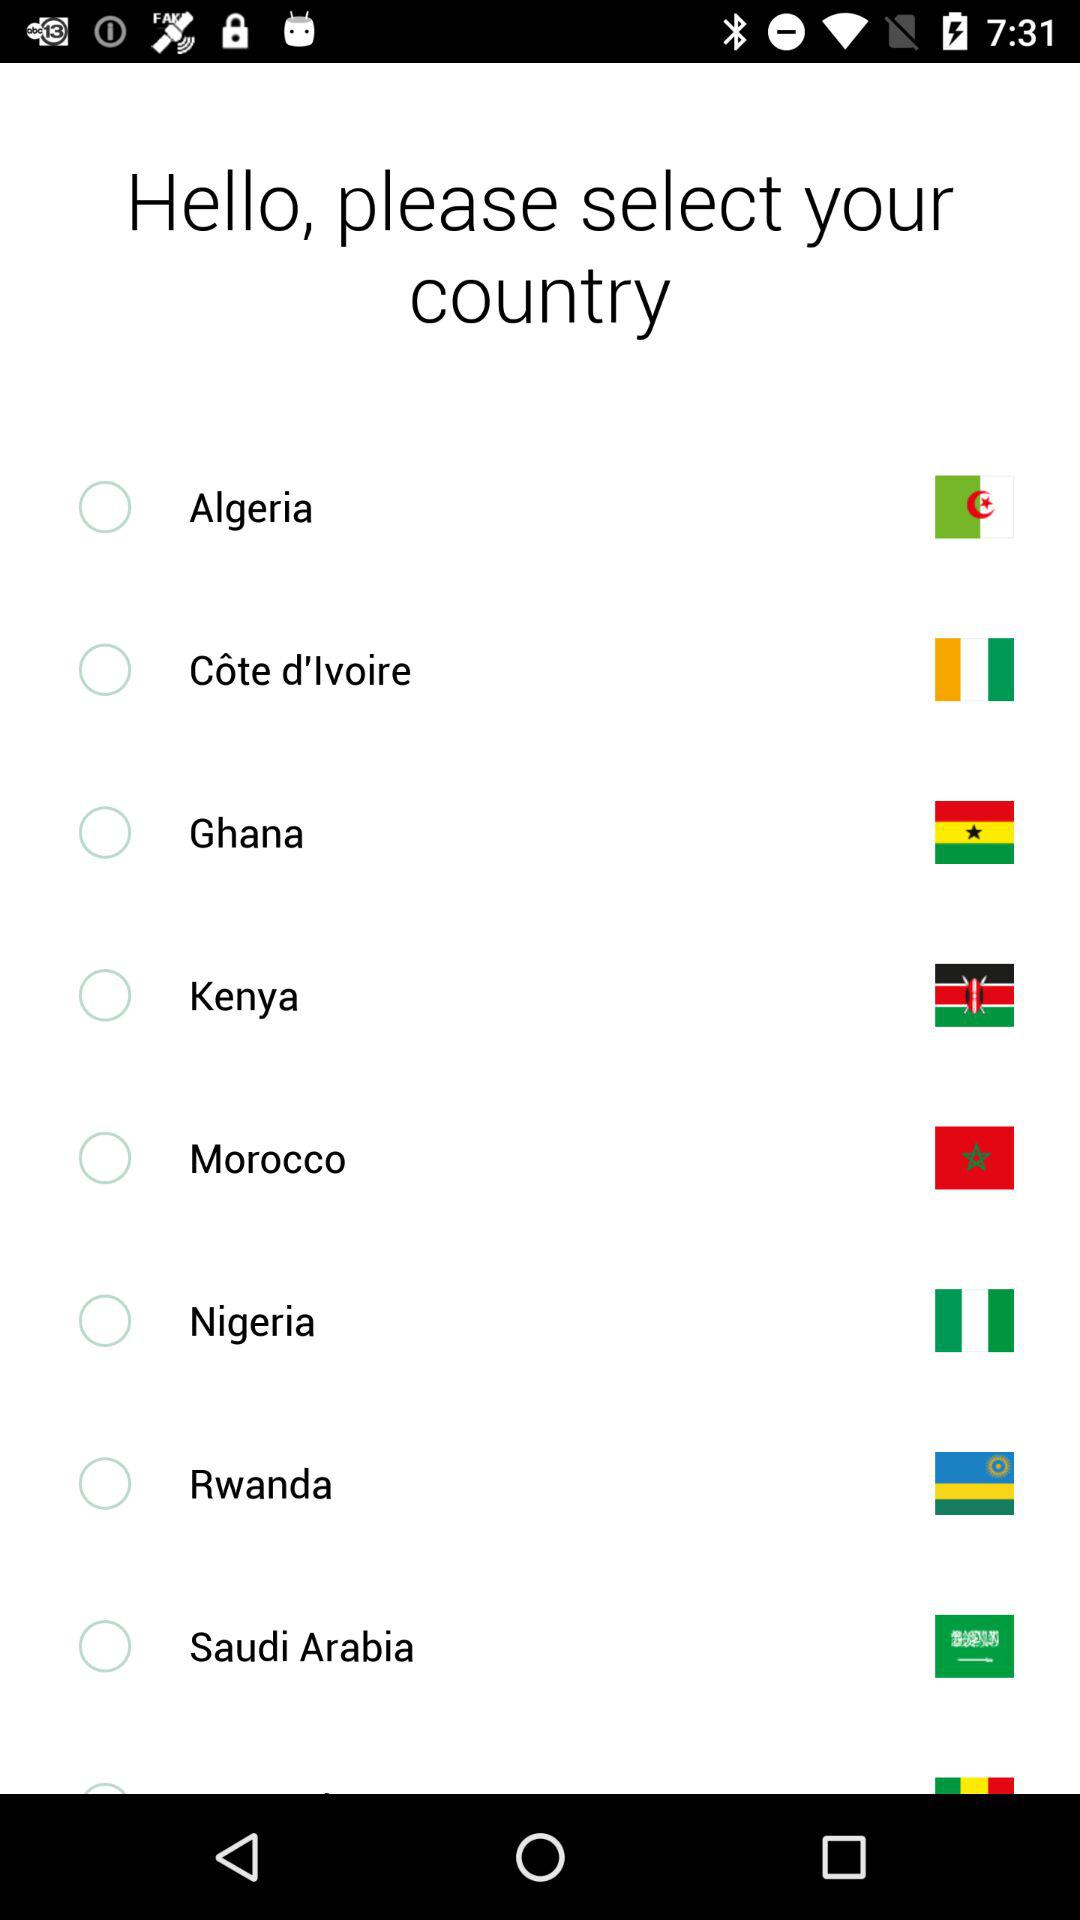What's the status of Algeria? The status is "off". 